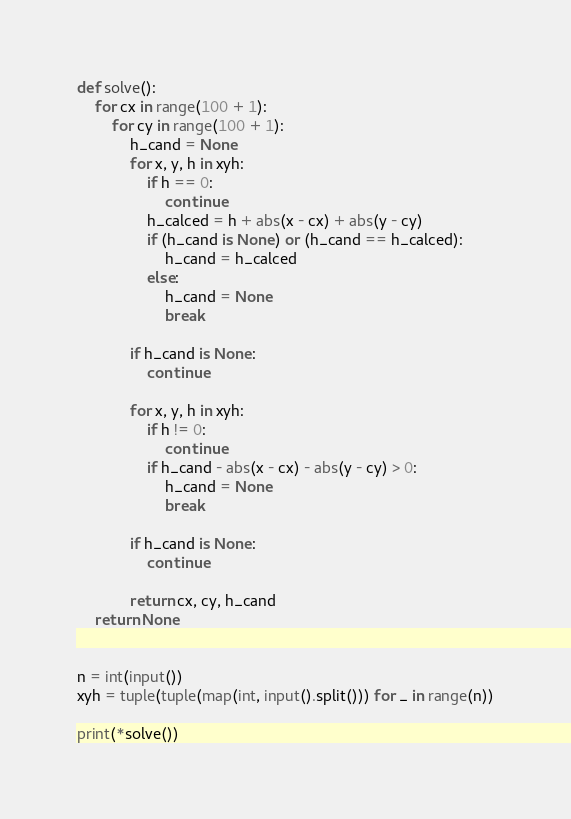<code> <loc_0><loc_0><loc_500><loc_500><_Python_>def solve():
    for cx in range(100 + 1):
        for cy in range(100 + 1):
            h_cand = None
            for x, y, h in xyh:
                if h == 0:
                    continue
                h_calced = h + abs(x - cx) + abs(y - cy)
                if (h_cand is None) or (h_cand == h_calced):
                    h_cand = h_calced
                else:
                    h_cand = None
                    break

            if h_cand is None:
                continue

            for x, y, h in xyh:
                if h != 0:
                    continue
                if h_cand - abs(x - cx) - abs(y - cy) > 0:
                    h_cand = None
                    break

            if h_cand is None:
                continue

            return cx, cy, h_cand
    return None


n = int(input())
xyh = tuple(tuple(map(int, input().split())) for _ in range(n))

print(*solve())
</code> 